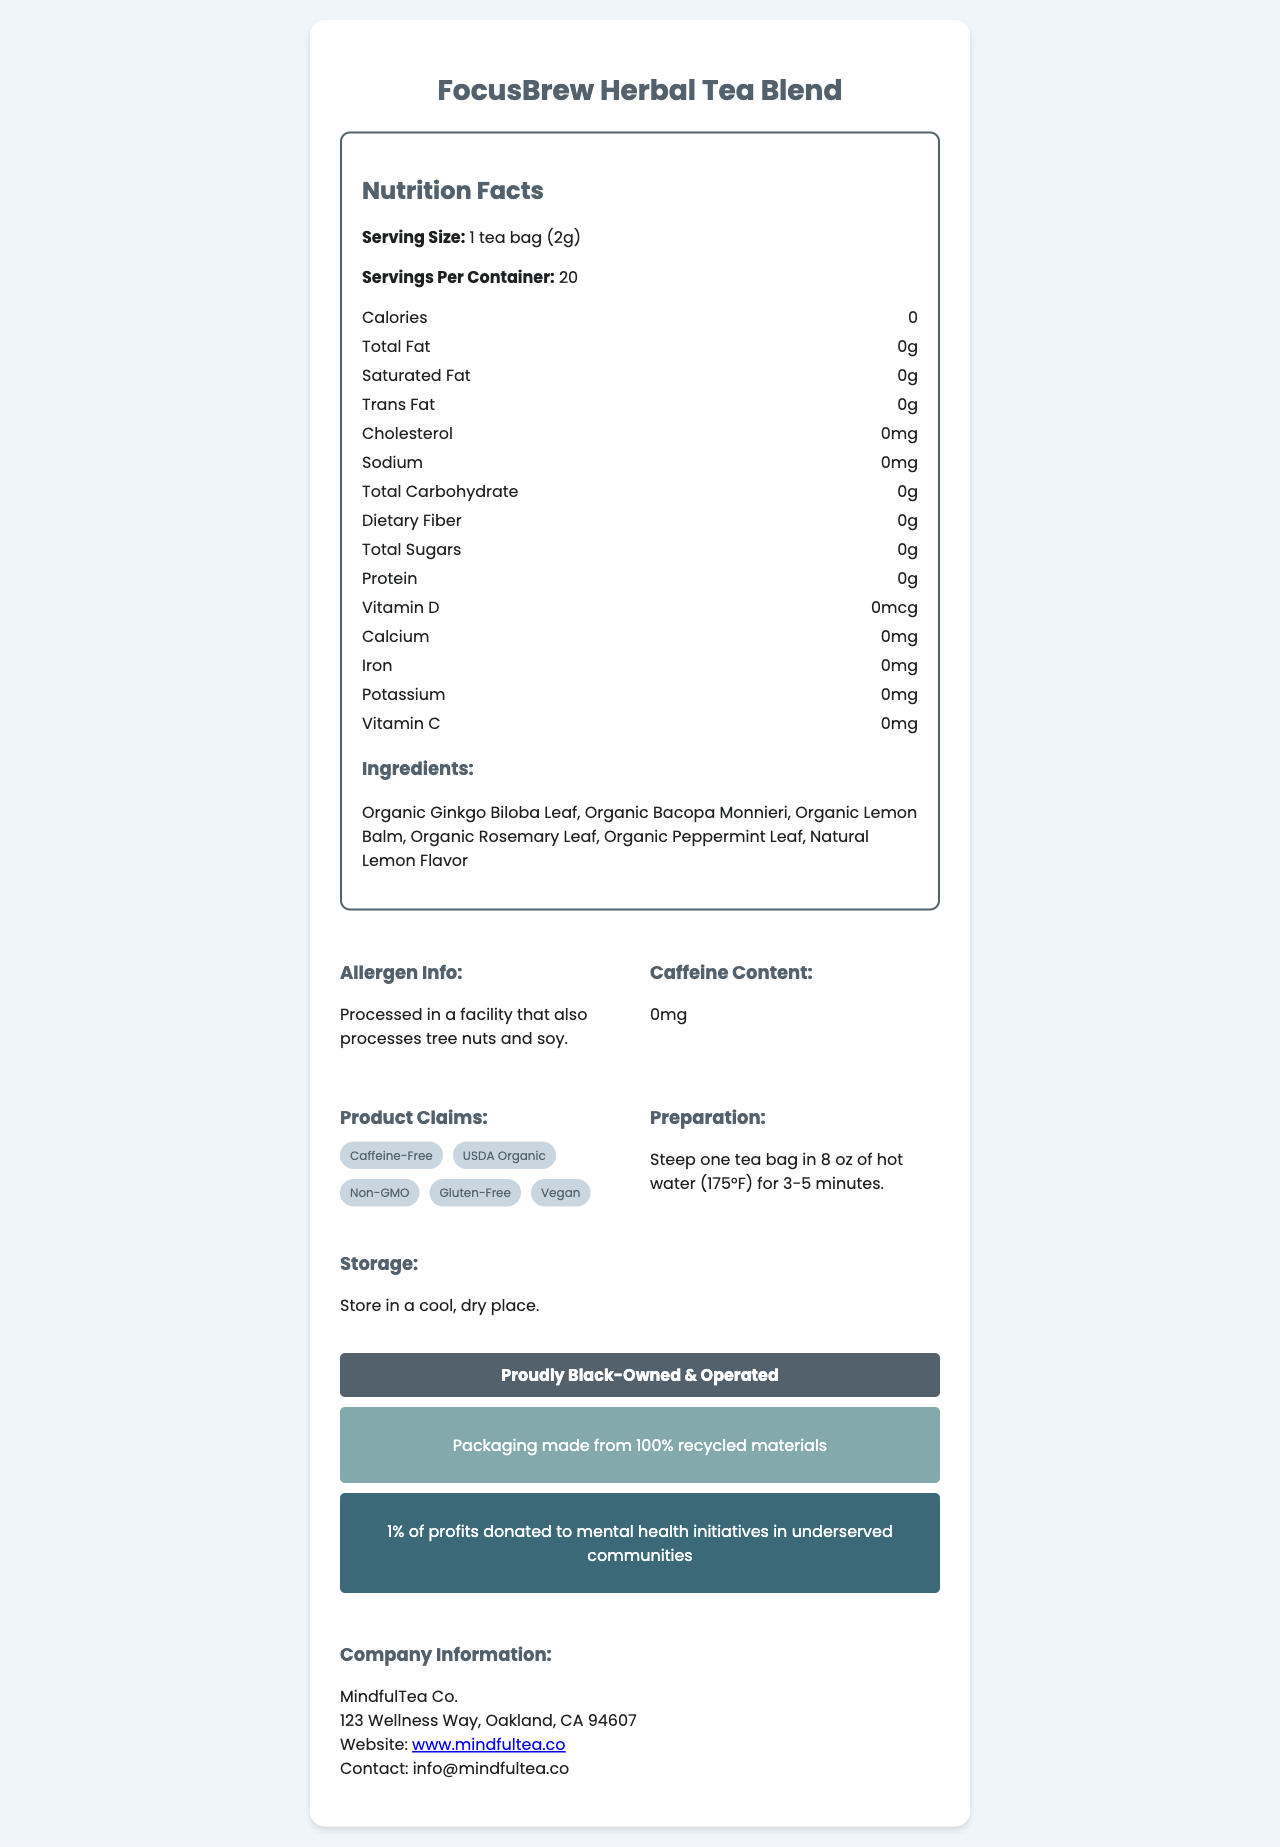What is the serving size of FocusBrew Herbal Tea Blend? The serving size is mentioned right at the top of the Nutrition Facts section.
Answer: 1 tea bag (2g) How many servings are there per container? The document states that each container has 20 servings.
Answer: 20 How many calories are in one serving of FocusBrew Herbal Tea Blend? The calories per serving are listed as 0 in the Nutrition Facts.
Answer: 0 What are the ingredients in FocusBrew Herbal Tea Blend? The Ingredients section lists all the components of the tea blend.
Answer: Organic Ginkgo Biloba Leaf, Organic Bacopa Monnieri, Organic Lemon Balm, Organic Rosemary Leaf, Organic Peppermint Leaf, Natural Lemon Flavor What kind of certification labels does the tea have? Under the Product Claims section, these certifications are listed as badges.
Answer: USDA Organic, Non-GMO, Gluten-Free, Vegan How should FocusBrew Herbal Tea Blend be stored? The Storage Instructions section provides this information.
Answer: Store in a cool, dry place How long should you steep the tea bag in hot water? The Preparation Instructions indicate that one tea bag should be steeped in 8 oz of hot water (175°F) for 3-5 minutes.
Answer: 3-5 minutes Which nutrients have a value of 0mg or 0g in this tea? A. Total Fat B. Sodium C. Total Carbohydrate D. All of the above All these nutrients are listed as having 0mg or 0g values in the Nutrition Facts.
Answer: D. All of the above What is the main claim about the caffeine content of this tea? A. Contains caffeine B. Low caffeine C. Caffeine-Free The Product Claims and Caffeine Content sections both assert that the tea is caffeine-free.
Answer: C. Caffeine-Free Does FocusBrew Herbal Tea Blend contain any preservatives? The document does not list any preservatives, and the ingredients are all-natural.
Answer: No Is MindfulTea Co. a minority-owned business? The Minority-Owned Business Label section mentions that it is "Proudly Black-Owned & Operated."
Answer: Yes Where is MindfulTea Co. located? The Company Information section lists the full address.
Answer: 123 Wellness Way, Oakland, CA 94607 What is the social impact commitment of MindfulTea Co.? This information is found in the Social Impact section.
Answer: 1% of profits donated to mental health initiatives in underserved communities What is the sustainability claim for the packaging? This claim is mentioned in the Sustainability Info section.
Answer: Packaging made from 100% recycled materials Summary: Describe the main points covered in the FocusBrew Herbal Tea Blend Nutrition Facts Label document. This summary captures the main contents and features covered in the document, including nutritional information, ingredients, company details, certifications, and social impact.
Answer: FocusBrew Herbal Tea Blend is a caffeine-free, organic, non-GMO, gluten-free, and vegan tea aimed at promoting focus and productivity. It contains no calories, fats, cholesterol, or sodium, and is made from all-natural ingredients like Ginkgo Biloba and Bacopa Monnieri. The tea is produced by MindfulTea Co., a Black-owned business that donates 1% of profits to mental health initiatives and uses 100% recycled packaging materials. Preparation involves steeping a tea bag in hot water for 3-5 minutes, and it should be stored in a cool, dry place. What is the percentage of daily value of Vitamin C in this tea? The document lists the amount of Vitamin C as 0mg, but it doesn't provide the percentage of the daily value.
Answer: Not enough information How many different types of leaves are used in the ingredients? A. Two B. Three C. Four D. Five The ingredients list mentions Organic Ginkgo Biloba Leaf, Organic Bacopa Monnieri, Organic Lemon Balm, Organic Rosemary Leaf, and Organic Peppermint Leaf, making it five types of leaves.
Answer: D. Five 